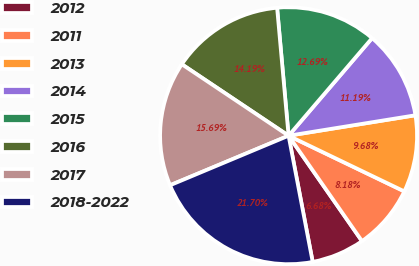<chart> <loc_0><loc_0><loc_500><loc_500><pie_chart><fcel>2012<fcel>2011<fcel>2013<fcel>2014<fcel>2015<fcel>2016<fcel>2017<fcel>2018-2022<nl><fcel>6.68%<fcel>8.18%<fcel>9.68%<fcel>11.19%<fcel>12.69%<fcel>14.19%<fcel>15.69%<fcel>21.7%<nl></chart> 